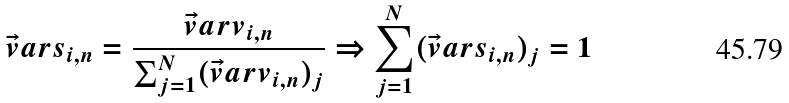<formula> <loc_0><loc_0><loc_500><loc_500>\vec { v } a r { s } _ { i , n } = \frac { \vec { v } a r { v } _ { i , n } } { \sum _ { j = 1 } ^ { N } ( \vec { v } a r { v } _ { i , n } ) _ { j } } \Rightarrow \sum _ { j = 1 } ^ { N } ( \vec { v } a r { s } _ { i , n } ) _ { j } = 1</formula> 